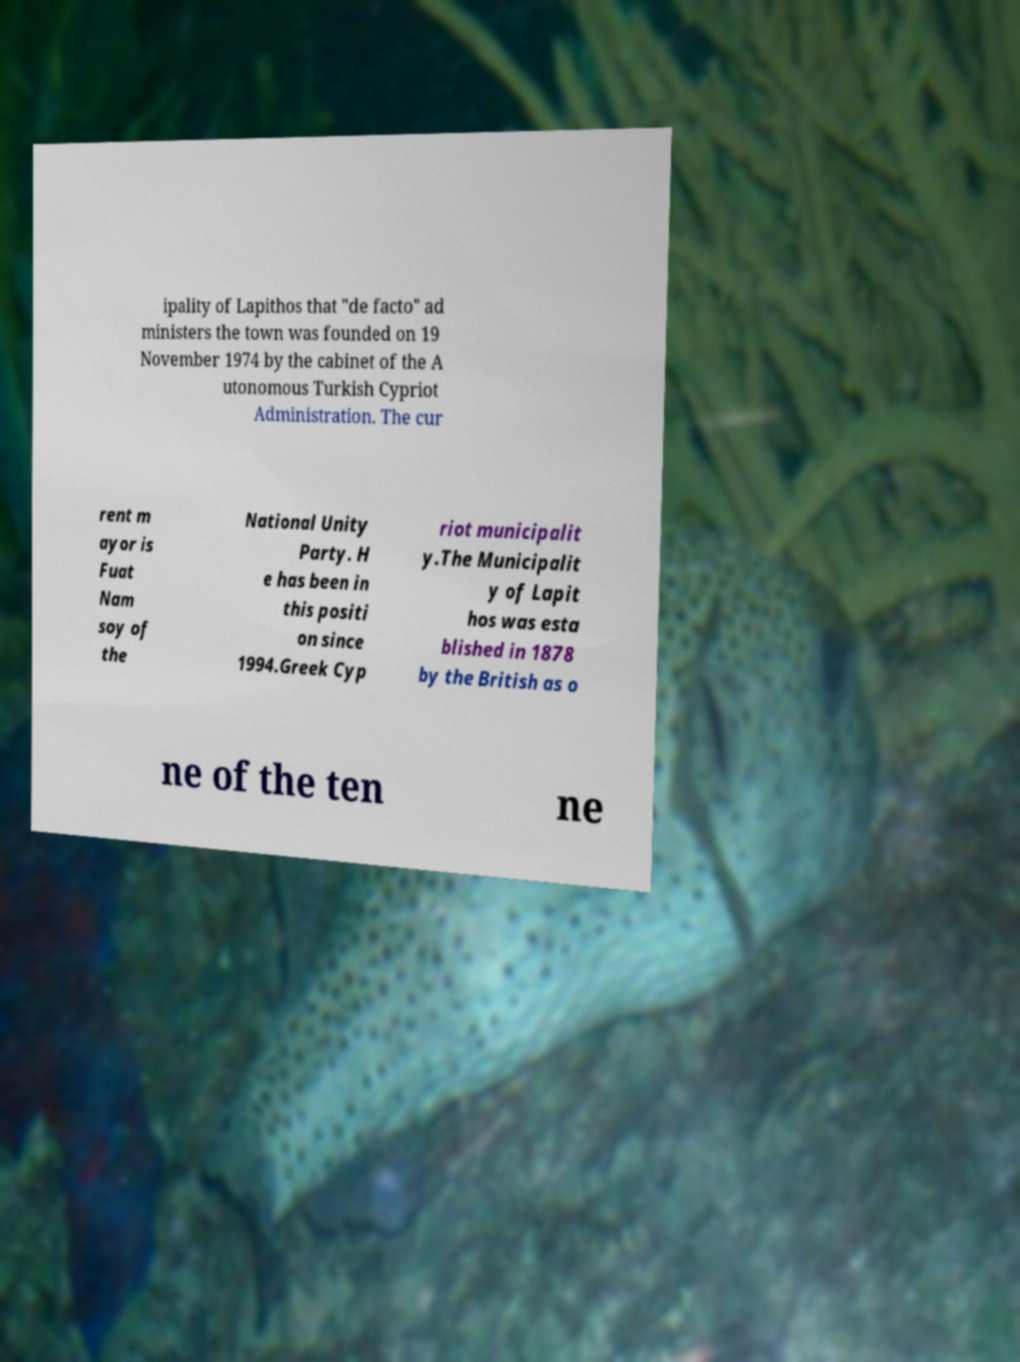Please identify and transcribe the text found in this image. ipality of Lapithos that "de facto" ad ministers the town was founded on 19 November 1974 by the cabinet of the A utonomous Turkish Cypriot Administration. The cur rent m ayor is Fuat Nam soy of the National Unity Party. H e has been in this positi on since 1994.Greek Cyp riot municipalit y.The Municipalit y of Lapit hos was esta blished in 1878 by the British as o ne of the ten ne 